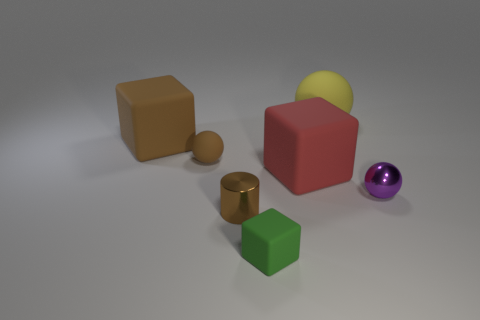There is a object that is both behind the brown rubber ball and on the left side of the big yellow matte object; what is its size?
Give a very brief answer. Large. How many large matte blocks are behind the large red rubber object?
Keep it short and to the point. 1. There is a big matte object that is on the right side of the cylinder and in front of the large yellow matte sphere; what is its shape?
Provide a short and direct response. Cube. What is the material of the big object that is the same color as the cylinder?
Provide a succinct answer. Rubber. How many cylinders are large purple matte things or purple things?
Your answer should be very brief. 0. There is a block that is the same color as the tiny shiny cylinder; what size is it?
Make the answer very short. Large. Are there fewer yellow matte things that are behind the big yellow thing than big yellow matte objects?
Your answer should be compact. Yes. What is the color of the rubber object that is in front of the large brown object and left of the small cylinder?
Provide a short and direct response. Brown. What number of other things are the same shape as the purple object?
Provide a short and direct response. 2. Is the number of matte objects in front of the brown matte cube less than the number of objects that are to the left of the red rubber block?
Make the answer very short. Yes. 